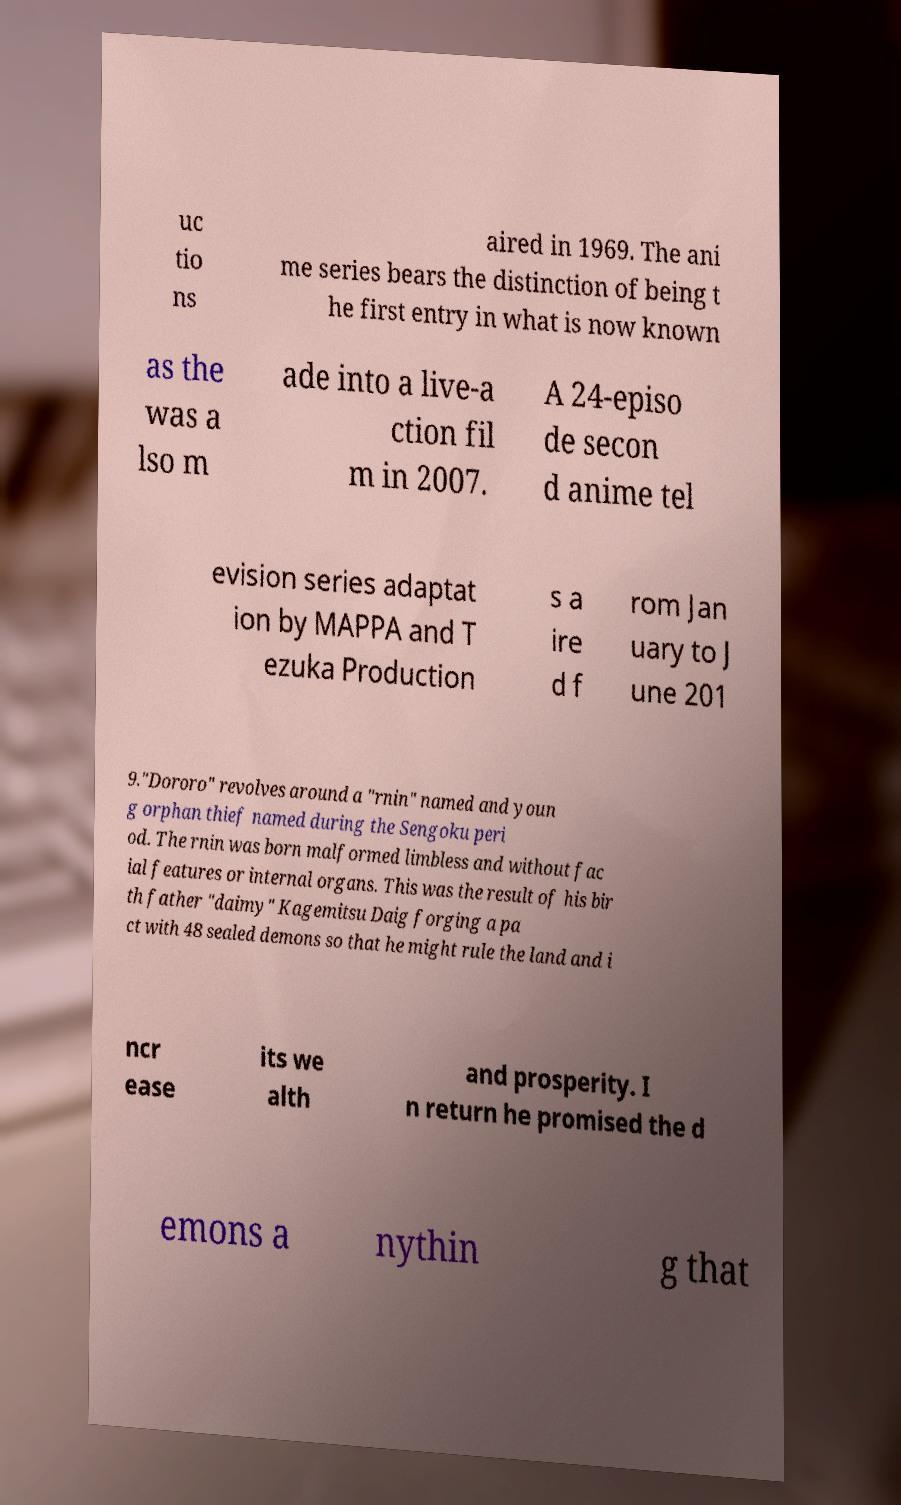Can you read and provide the text displayed in the image?This photo seems to have some interesting text. Can you extract and type it out for me? uc tio ns aired in 1969. The ani me series bears the distinction of being t he first entry in what is now known as the was a lso m ade into a live-a ction fil m in 2007. A 24-episo de secon d anime tel evision series adaptat ion by MAPPA and T ezuka Production s a ire d f rom Jan uary to J une 201 9."Dororo" revolves around a "rnin" named and youn g orphan thief named during the Sengoku peri od. The rnin was born malformed limbless and without fac ial features or internal organs. This was the result of his bir th father "daimy" Kagemitsu Daig forging a pa ct with 48 sealed demons so that he might rule the land and i ncr ease its we alth and prosperity. I n return he promised the d emons a nythin g that 